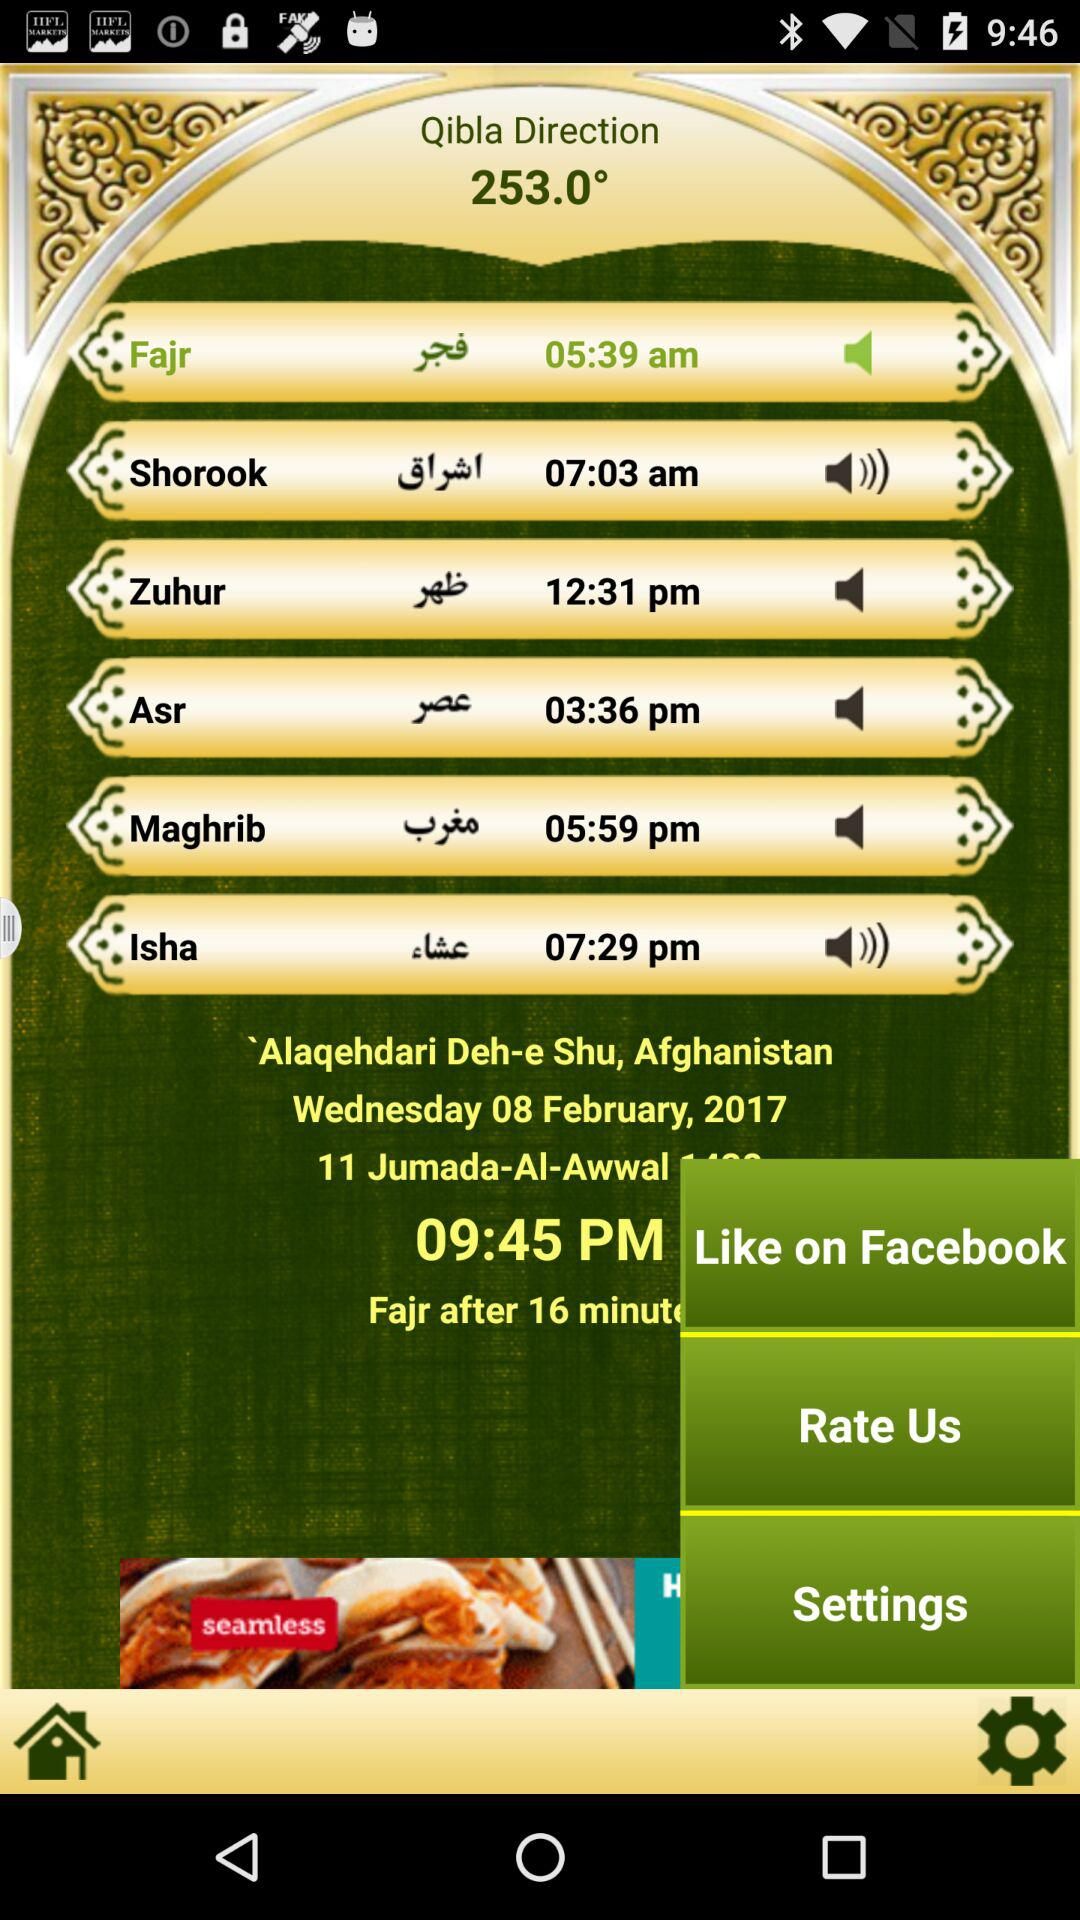What is the time of Fajr? The time is 05:39 am. 